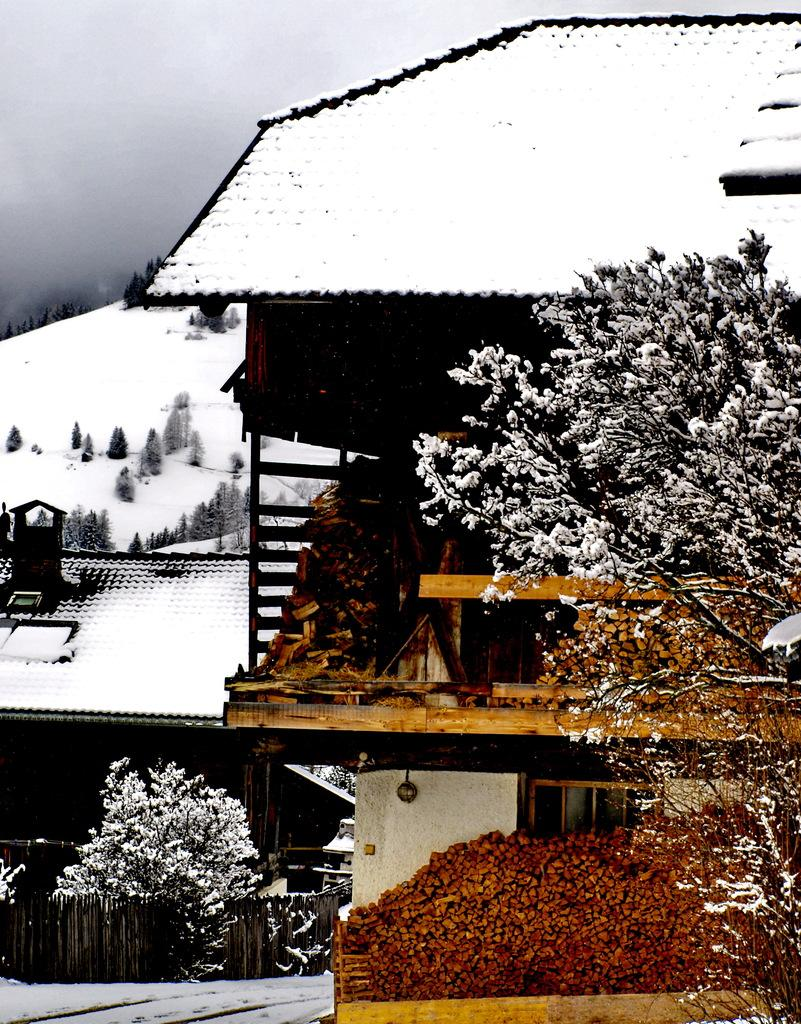What type of structures can be seen in the image? There are sheds in the image. What other natural elements are present in the image? There are trees in the image. What can be seen in the distance in the image? There is a hill visible in the background of the image. What is visible in the sky in the image? The sky is visible in the background of the image. What is the weather like in the image? The presence of snow in the image suggests that it is a snowy or winter scene. What type of jam is being spread on the watch in the image? There is no watch or jam present in the image. What type of learning is taking place in the image? There is no learning activity depicted in the image; it features sheds, trees, a hill, and snow. 